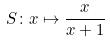<formula> <loc_0><loc_0><loc_500><loc_500>S \colon x \mapsto \frac { x } { x + 1 }</formula> 